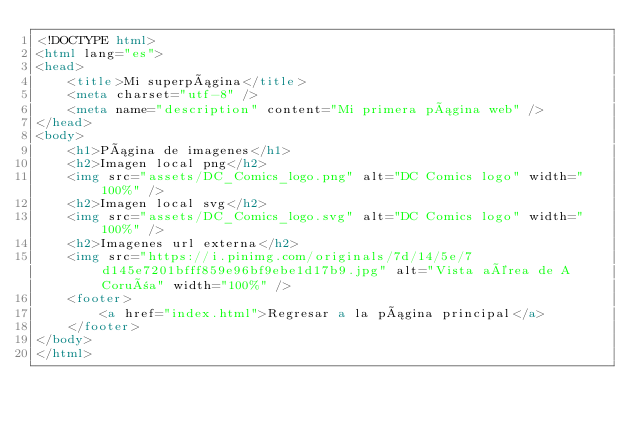Convert code to text. <code><loc_0><loc_0><loc_500><loc_500><_HTML_><!DOCTYPE html>
<html lang="es">
<head>
    <title>Mi superpágina</title>
    <meta charset="utf-8" />
    <meta name="description" content="Mi primera página web" />
</head>
<body>
    <h1>Página de imagenes</h1>
    <h2>Imagen local png</h2>
    <img src="assets/DC_Comics_logo.png" alt="DC Comics logo" width="100%" />
    <h2>Imagen local svg</h2>
    <img src="assets/DC_Comics_logo.svg" alt="DC Comics logo" width="100%" />
    <h2>Imagenes url externa</h2>
    <img src="https://i.pinimg.com/originals/7d/14/5e/7d145e7201bfff859e96bf9ebe1d17b9.jpg" alt="Vista aérea de A Coruña" width="100%" />
    <footer>
        <a href="index.html">Regresar a la página principal</a>
    </footer>
</body>
</html>
</code> 